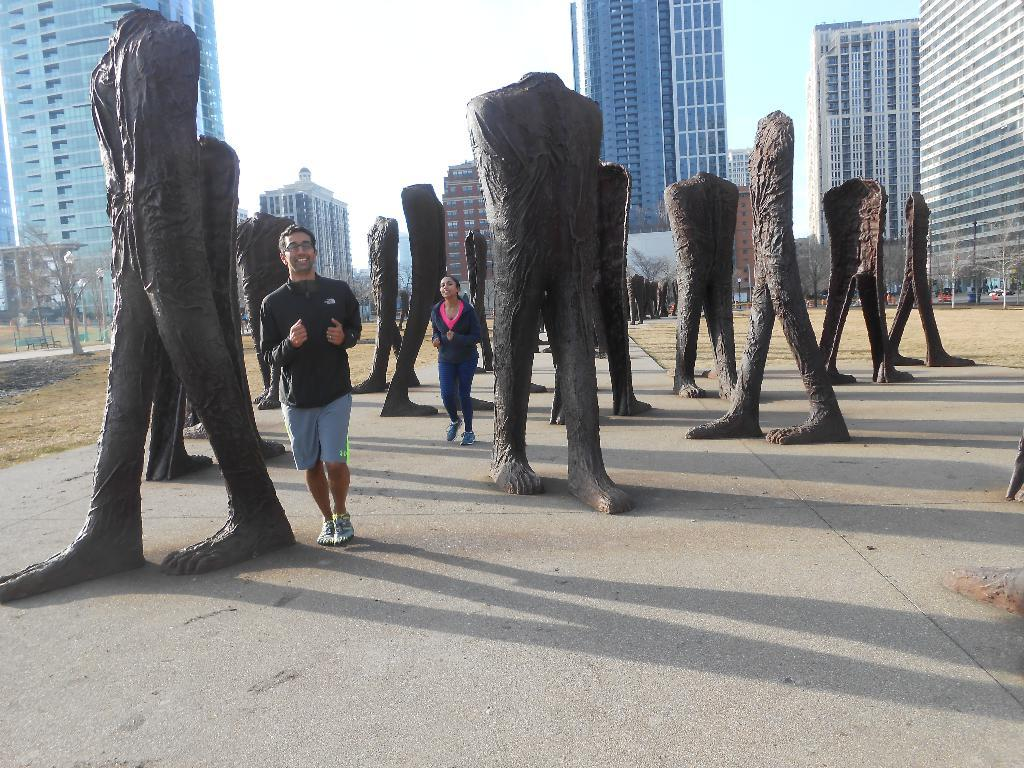What type of art is present in the image? There are sculptures in the image. Can you describe the people in the image? There are people in the image, and they are in the middle of the image. What can be seen in the background of the image? There are buildings and trees in the background of the image. What type of bushes can be seen in the image? There are no bushes present in the image. Who is the daughter of the person in the image? There is no information about a daughter or any familial relationships in the image. 